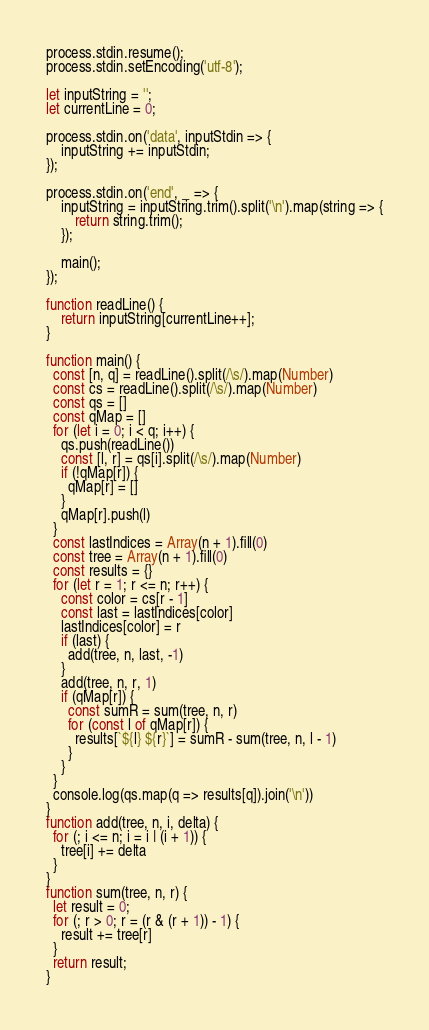Convert code to text. <code><loc_0><loc_0><loc_500><loc_500><_JavaScript_>process.stdin.resume();
process.stdin.setEncoding('utf-8');
 
let inputString = '';
let currentLine = 0;
 
process.stdin.on('data', inputStdin => {
    inputString += inputStdin;
});
 
process.stdin.on('end', _ => {
    inputString = inputString.trim().split('\n').map(string => {
        return string.trim();
    });
    
    main();    
});
 
function readLine() {
    return inputString[currentLine++];
}

function main() {
  const [n, q] = readLine().split(/\s/).map(Number)
  const cs = readLine().split(/\s/).map(Number)
  const qs = []
  const qMap = []
  for (let i = 0; i < q; i++) {
    qs.push(readLine())
    const [l, r] = qs[i].split(/\s/).map(Number)
    if (!qMap[r]) {
      qMap[r] = []
    }
    qMap[r].push(l)
  }
  const lastIndices = Array(n + 1).fill(0)
  const tree = Array(n + 1).fill(0)
  const results = {}
  for (let r = 1; r <= n; r++) {
    const color = cs[r - 1]
    const last = lastIndices[color]
    lastIndices[color] = r
    if (last) {
      add(tree, n, last, -1)
    }
    add(tree, n, r, 1)
    if (qMap[r]) {
      const sumR = sum(tree, n, r)
      for (const l of qMap[r]) {
	    results[`${l} ${r}`] = sumR - sum(tree, n, l - 1)
      }
    }
  }
  console.log(qs.map(q => results[q]).join('\n'))
}
function add(tree, n, i, delta) {
  for (; i <= n; i = i | (i + 1)) {
    tree[i] += delta
  }
}
function sum(tree, n, r) {
  let result = 0;
  for (; r > 0; r = (r & (r + 1)) - 1) {
    result += tree[r]
  }
  return result;
}</code> 